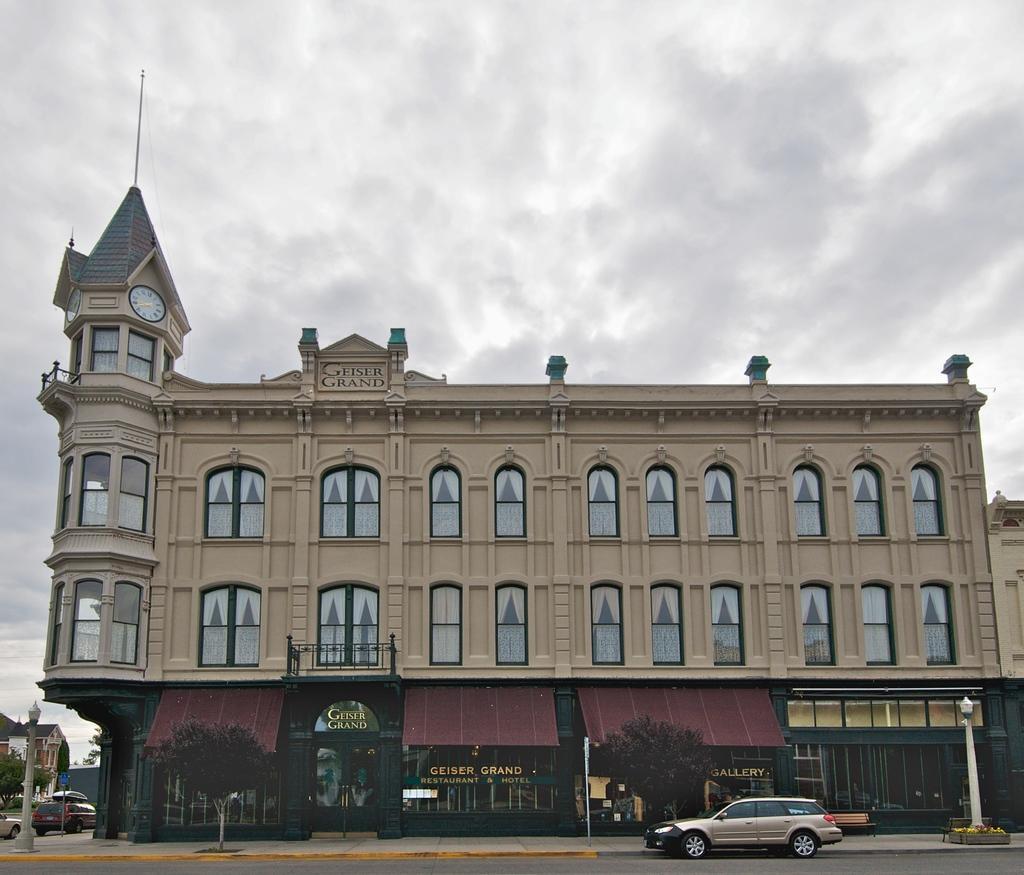Describe this image in one or two sentences. In the center of the image there is a building. At the bottom there are trees and poles. We can see cars. On the left there are buildings. In the background there is sky. 